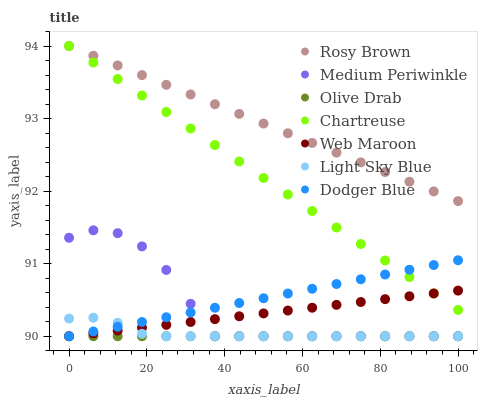Does Olive Drab have the minimum area under the curve?
Answer yes or no. Yes. Does Rosy Brown have the maximum area under the curve?
Answer yes or no. Yes. Does Web Maroon have the minimum area under the curve?
Answer yes or no. No. Does Web Maroon have the maximum area under the curve?
Answer yes or no. No. Is Olive Drab the smoothest?
Answer yes or no. Yes. Is Medium Periwinkle the roughest?
Answer yes or no. Yes. Is Rosy Brown the smoothest?
Answer yes or no. No. Is Rosy Brown the roughest?
Answer yes or no. No. Does Medium Periwinkle have the lowest value?
Answer yes or no. Yes. Does Rosy Brown have the lowest value?
Answer yes or no. No. Does Chartreuse have the highest value?
Answer yes or no. Yes. Does Web Maroon have the highest value?
Answer yes or no. No. Is Medium Periwinkle less than Rosy Brown?
Answer yes or no. Yes. Is Chartreuse greater than Medium Periwinkle?
Answer yes or no. Yes. Does Olive Drab intersect Dodger Blue?
Answer yes or no. Yes. Is Olive Drab less than Dodger Blue?
Answer yes or no. No. Is Olive Drab greater than Dodger Blue?
Answer yes or no. No. Does Medium Periwinkle intersect Rosy Brown?
Answer yes or no. No. 